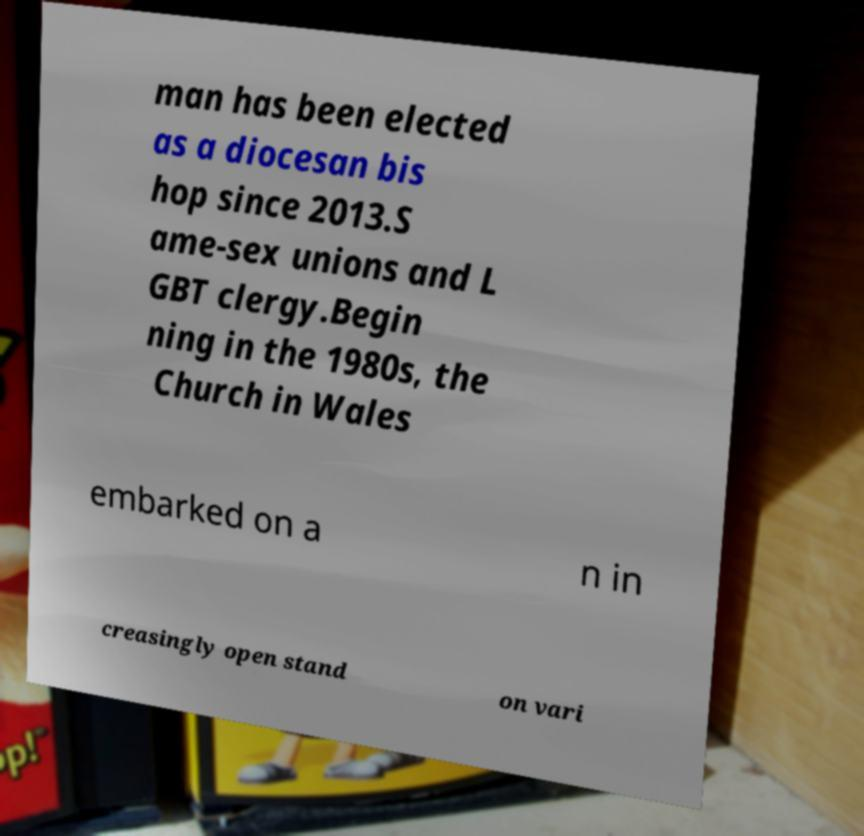Could you assist in decoding the text presented in this image and type it out clearly? man has been elected as a diocesan bis hop since 2013.S ame-sex unions and L GBT clergy.Begin ning in the 1980s, the Church in Wales embarked on a n in creasingly open stand on vari 